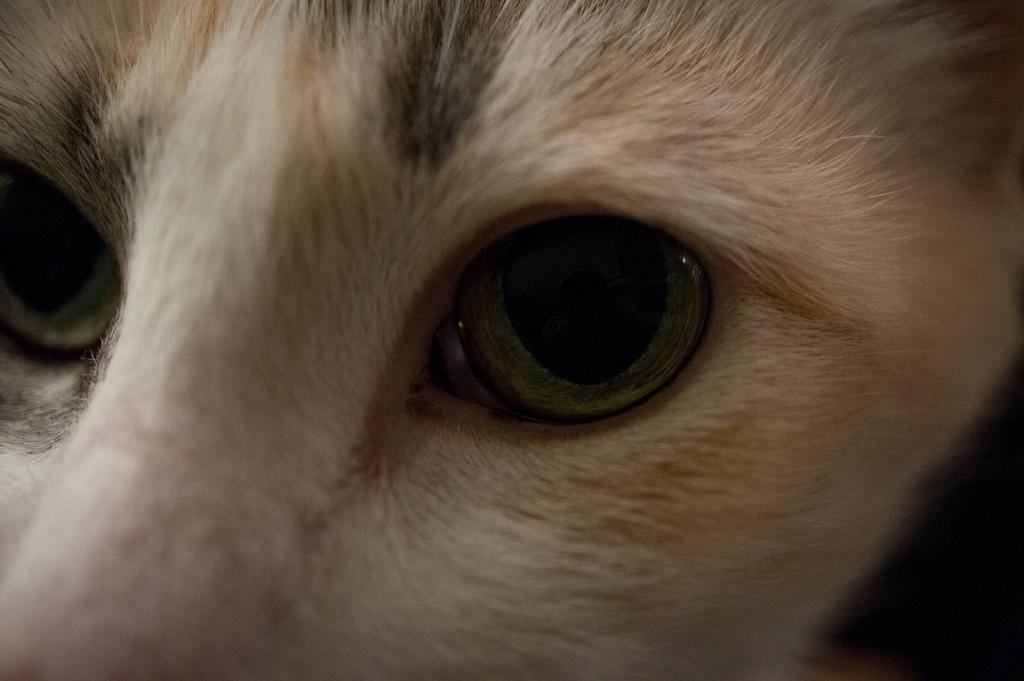What is the main subject of the image? The main subject of the image is an animal face. What features can be seen on the animal face? The animal face has eyes. What type of smile can be seen on the animal face in the image? There is no smile visible on the animal face in the image. What season is depicted in the image? The provided facts do not mention any season or weather-related details. What type of gardening tool is present in the image? There is no gardening tool, such as a rake, present in the image. 